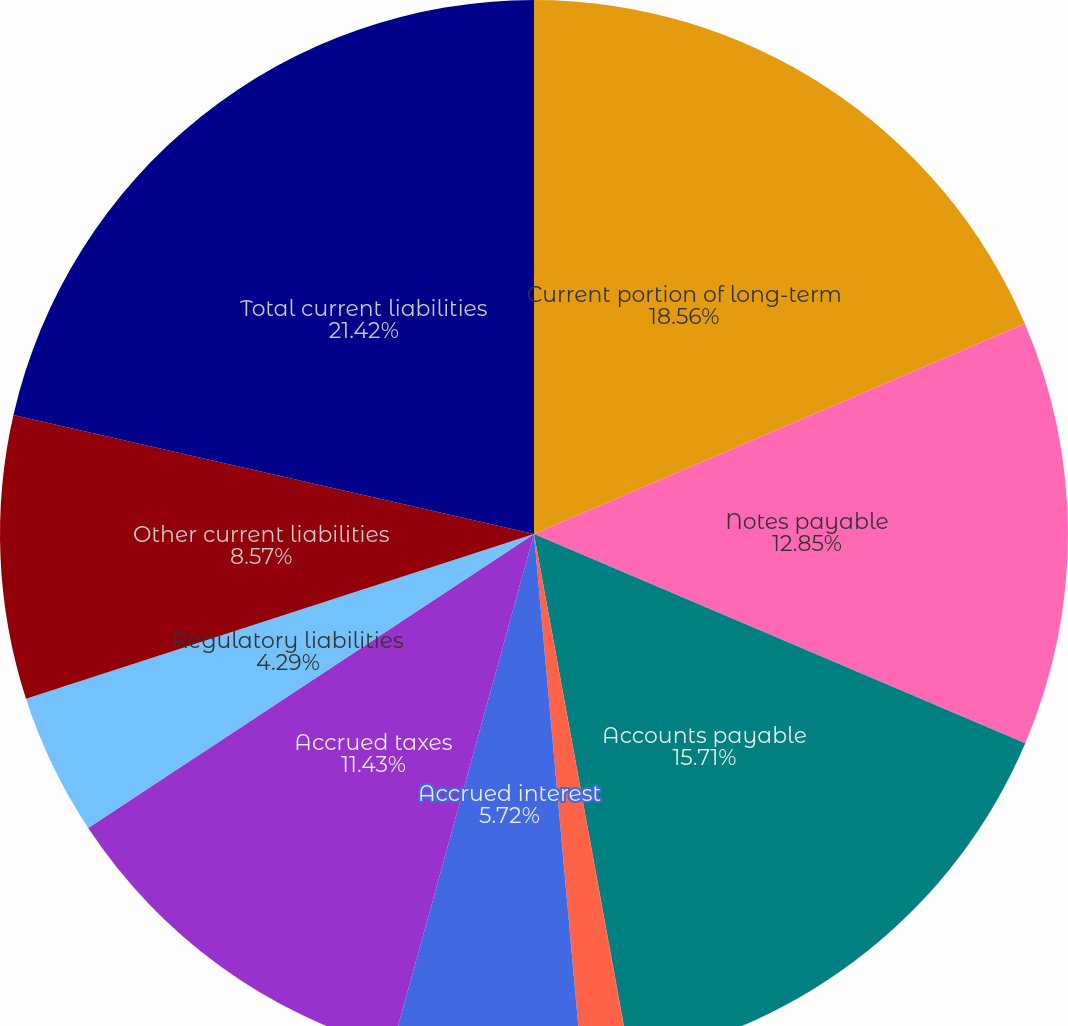<chart> <loc_0><loc_0><loc_500><loc_500><pie_chart><fcel>Current portion of long-term<fcel>Notes payable<fcel>Accounts payable<fcel>Accounts payable - related<fcel>Accrued rate refunds<fcel>Accrued interest<fcel>Accrued taxes<fcel>Regulatory liabilities<fcel>Other current liabilities<fcel>Total current liabilities<nl><fcel>18.56%<fcel>12.85%<fcel>15.71%<fcel>0.01%<fcel>1.44%<fcel>5.72%<fcel>11.43%<fcel>4.29%<fcel>8.57%<fcel>21.42%<nl></chart> 